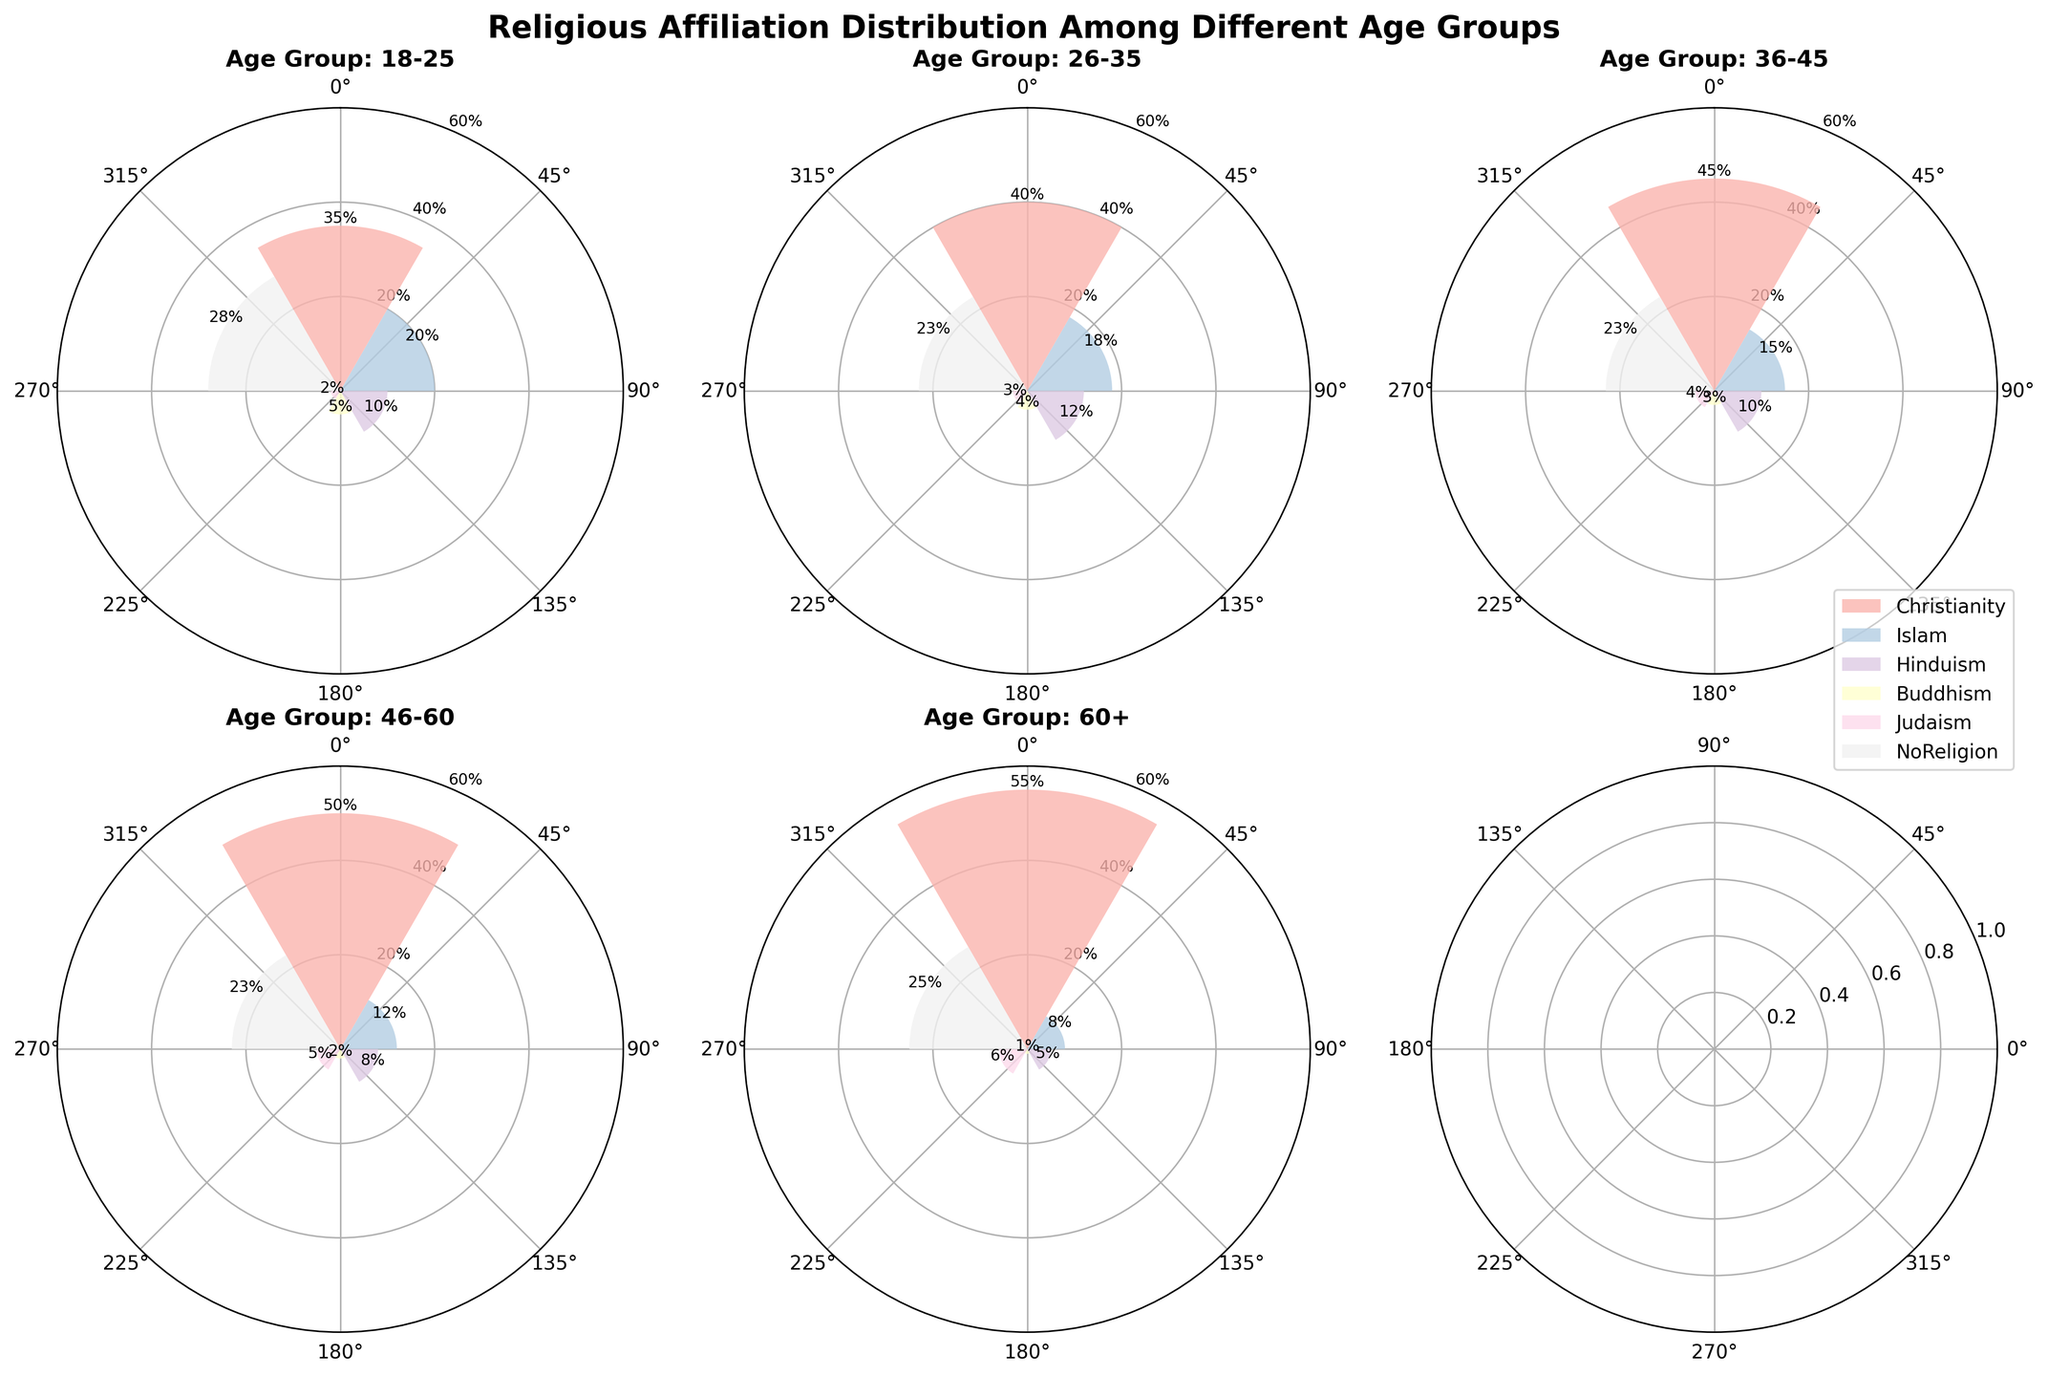What is the title of the figure? The title is given at the top center of the figure in bold and larger font, which reads "Religious Affiliation Distribution Among Different Age Groups".
Answer: Religious Affiliation Distribution Among Different Age Groups Which age group has the highest percentage of people with no religious affiliation? Looking at the subplots, you can find that the largest segment for "NoReligion" is in the age group 18-25. The value is 28%.
Answer: 18-25 What is the difference in percentage between Christianity and Islam for the age group 46-60? For age group 46-60, the percentage for Christianity is 50% and for Islam, it is 12%. The difference is calculated as 50% - 12% = 38%.
Answer: 38% Which religion has the lowest percentage in the age group 36-45? For age group 36-45, looking at the length of the bars, Buddhism has the fewest percentage at 3%.
Answer: Buddhism How does the percentage of Hinduism change from the age group 18-25 to the age group 60+? For age group 18-25, the percentage for Hinduism is 10%, and for age group 60+, it is 5%. The change is a decrease of 5%.
Answer: Decreases by 5% What percentage of the 26-35 age group identifies as Judaism? For the age group 26-35, the percentage for Judaism is 3%, as indicated by one of the segments in the rose chart.
Answer: 3% Does the proportion of people identifying as Christianity increase or decrease with age? Observing the radial segments from each subplot, the proportion of people identifying as Christianity increases with age. It starts at 35% for 18-25 and rises to 55% for 60+.
Answer: Increase How many subplots are present in the figure? There are six subplots present, representing five age groups, as can be seen from the arrangement of the plots.
Answer: Six What age group has the highest percentage for the Buddhism religion? Examining all the subplots, the age group 18-25 has the highest percentage for Buddhism at 5%.
Answer: 18-25 What is the average percentage of NoReligion for the age groups plotted? NoReligion percentages for the groups are 28%, 23%, 23%, 23%, and 25%. The average is (28 + 23 + 23 + 23 + 25) / 5 = 24.4%.
Answer: 24.4% 